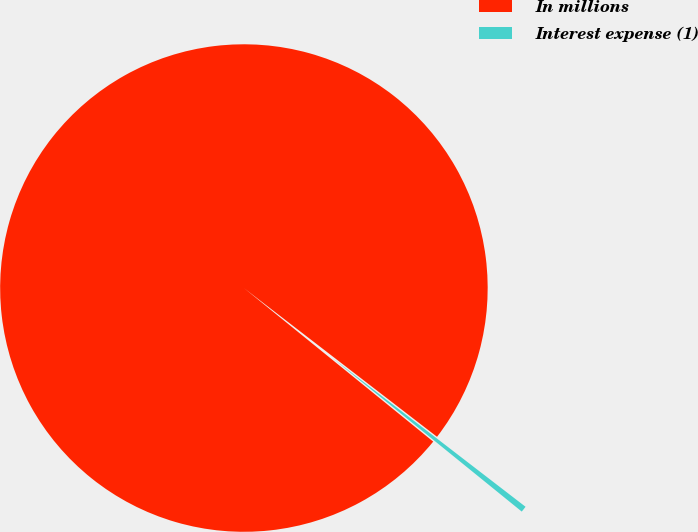<chart> <loc_0><loc_0><loc_500><loc_500><pie_chart><fcel>In millions<fcel>Interest expense (1)<nl><fcel>99.6%<fcel>0.4%<nl></chart> 